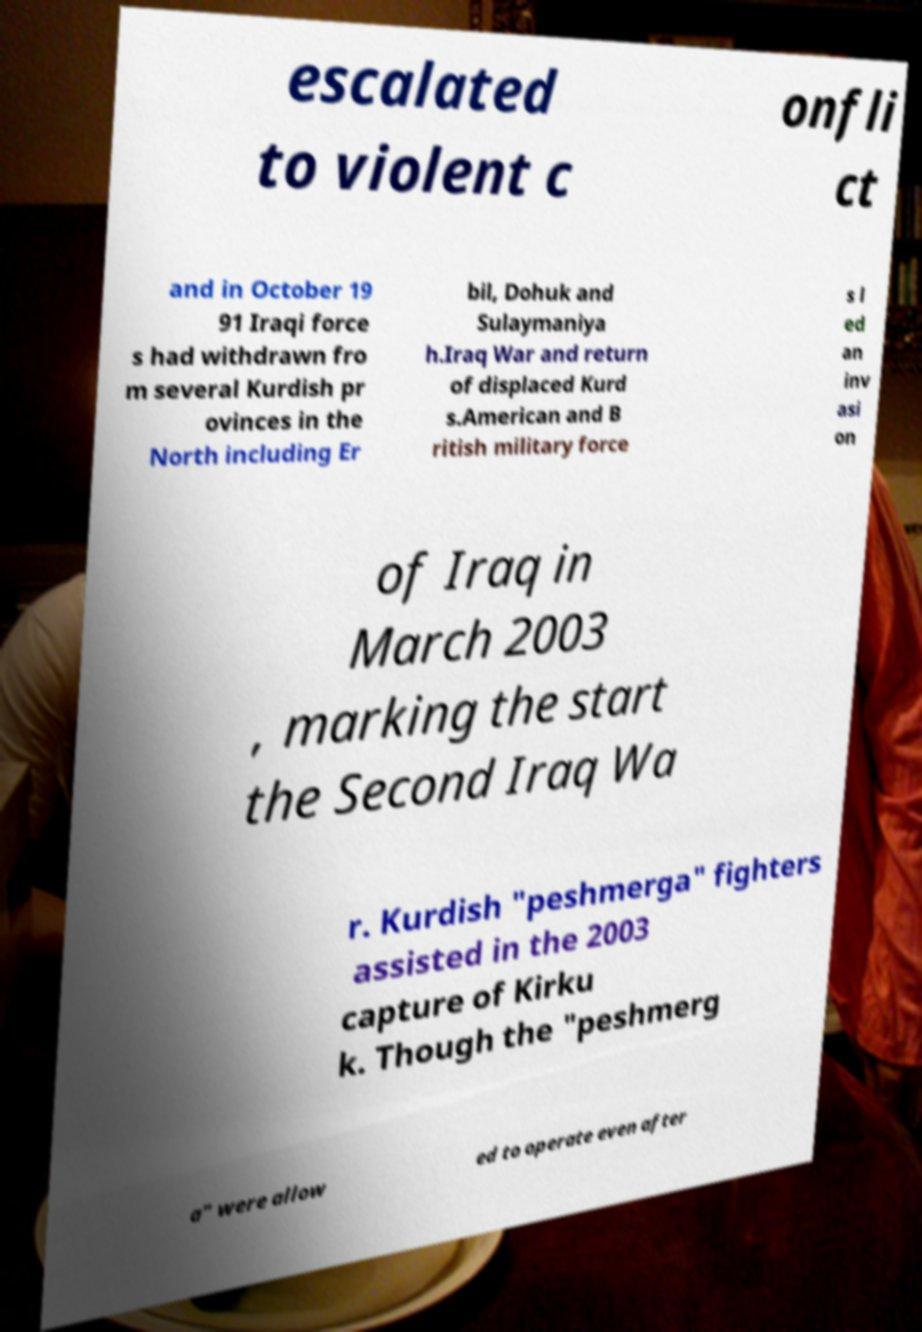Can you accurately transcribe the text from the provided image for me? escalated to violent c onfli ct and in October 19 91 Iraqi force s had withdrawn fro m several Kurdish pr ovinces in the North including Er bil, Dohuk and Sulaymaniya h.Iraq War and return of displaced Kurd s.American and B ritish military force s l ed an inv asi on of Iraq in March 2003 , marking the start the Second Iraq Wa r. Kurdish "peshmerga" fighters assisted in the 2003 capture of Kirku k. Though the "peshmerg a" were allow ed to operate even after 